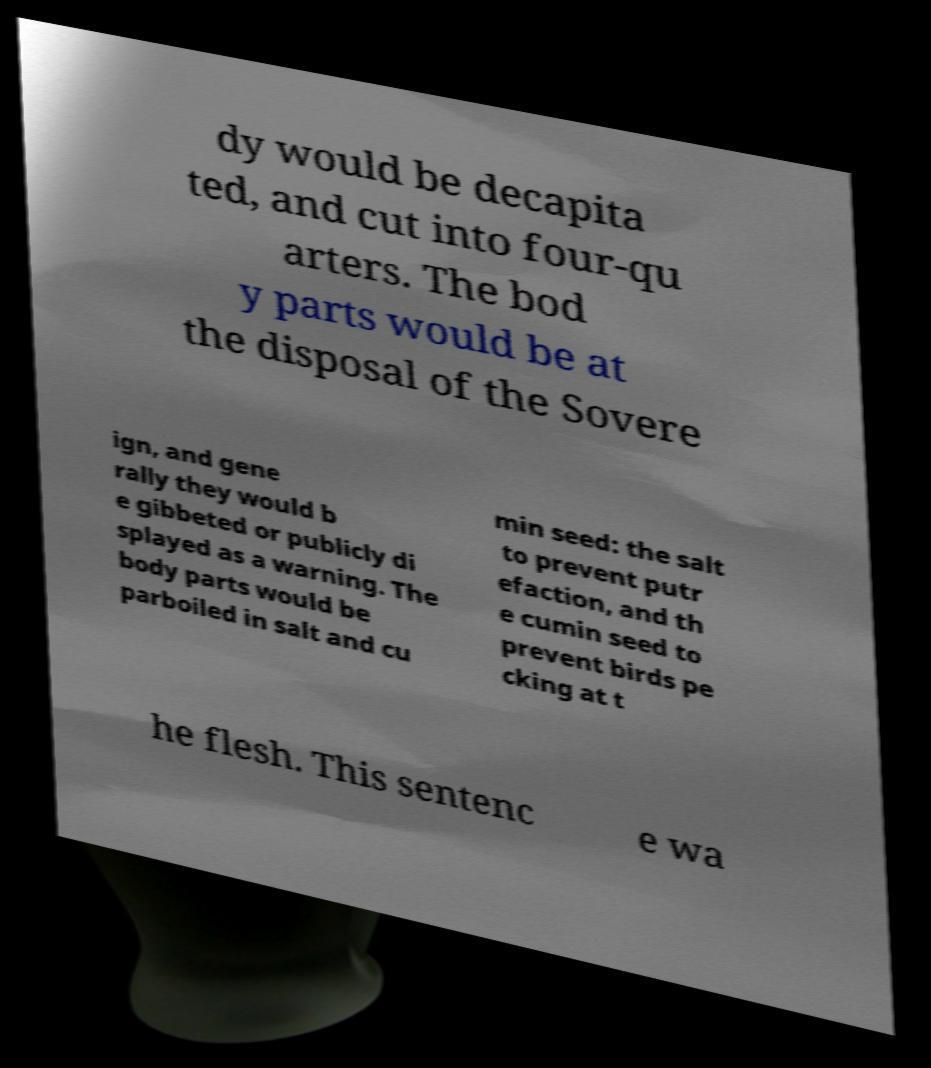I need the written content from this picture converted into text. Can you do that? dy would be decapita ted, and cut into four-qu arters. The bod y parts would be at the disposal of the Sovere ign, and gene rally they would b e gibbeted or publicly di splayed as a warning. The body parts would be parboiled in salt and cu min seed: the salt to prevent putr efaction, and th e cumin seed to prevent birds pe cking at t he flesh. This sentenc e wa 